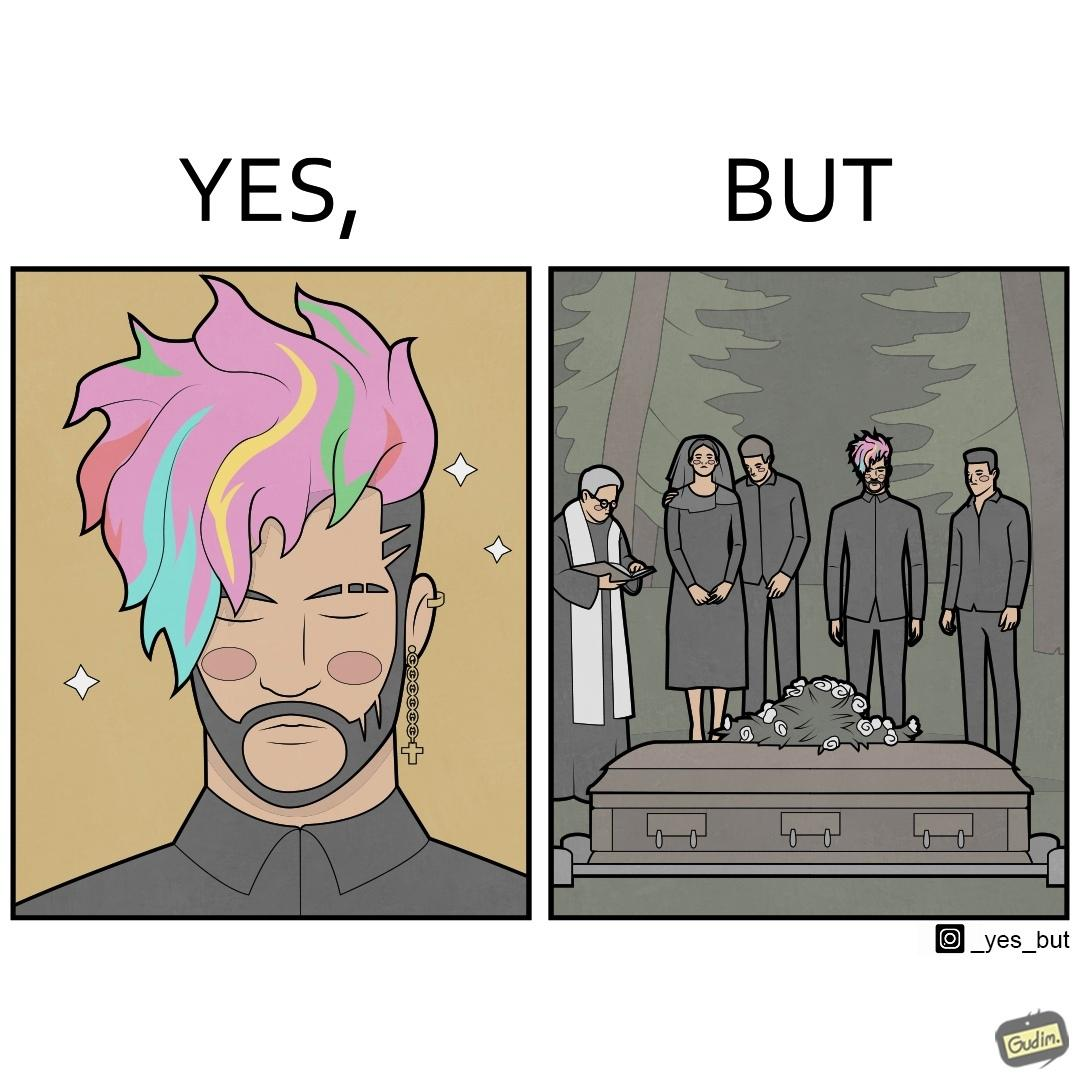Describe the satirical element in this image. The image is ironic, because in the second image it is shown that a group of people is attending someone's death ceremony but one of them is shown as wrongly dressed for that place in first image, his visual appearances doesn't shows his feeling of mourning 